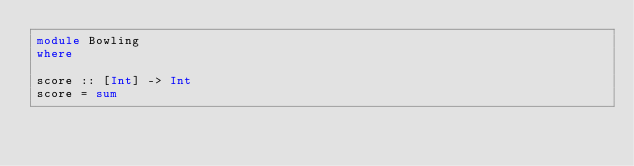<code> <loc_0><loc_0><loc_500><loc_500><_Haskell_>module Bowling
where

score :: [Int] -> Int
score = sum

</code> 